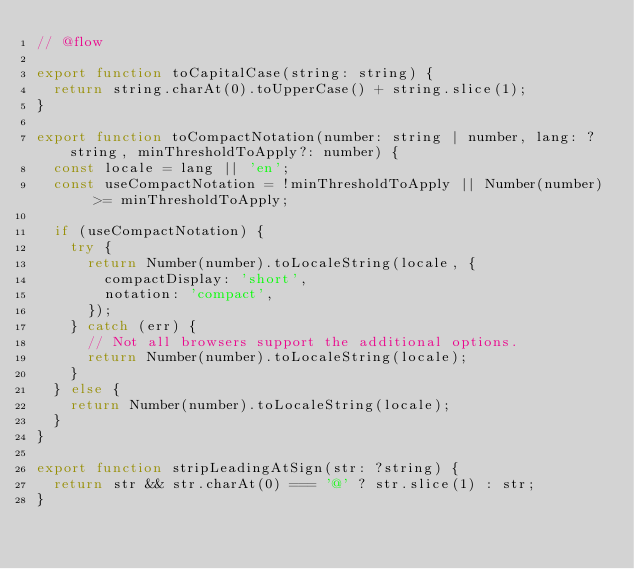<code> <loc_0><loc_0><loc_500><loc_500><_JavaScript_>// @flow

export function toCapitalCase(string: string) {
  return string.charAt(0).toUpperCase() + string.slice(1);
}

export function toCompactNotation(number: string | number, lang: ?string, minThresholdToApply?: number) {
  const locale = lang || 'en';
  const useCompactNotation = !minThresholdToApply || Number(number) >= minThresholdToApply;

  if (useCompactNotation) {
    try {
      return Number(number).toLocaleString(locale, {
        compactDisplay: 'short',
        notation: 'compact',
      });
    } catch (err) {
      // Not all browsers support the additional options.
      return Number(number).toLocaleString(locale);
    }
  } else {
    return Number(number).toLocaleString(locale);
  }
}

export function stripLeadingAtSign(str: ?string) {
  return str && str.charAt(0) === '@' ? str.slice(1) : str;
}
</code> 